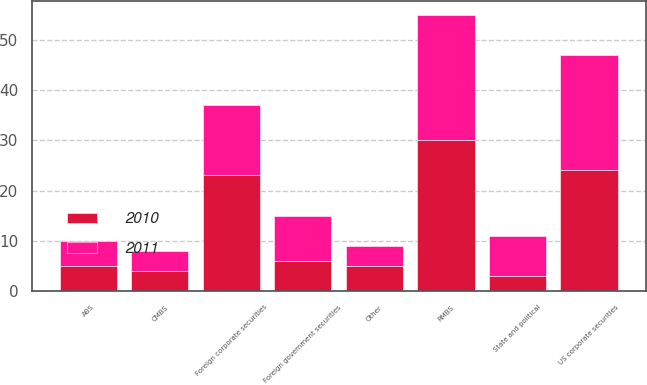Convert chart to OTSL. <chart><loc_0><loc_0><loc_500><loc_500><stacked_bar_chart><ecel><fcel>RMBS<fcel>US corporate securities<fcel>Foreign corporate securities<fcel>Foreign government securities<fcel>ABS<fcel>CMBS<fcel>State and political<fcel>Other<nl><fcel>2010<fcel>30<fcel>24<fcel>23<fcel>6<fcel>5<fcel>4<fcel>3<fcel>5<nl><fcel>2011<fcel>25<fcel>23<fcel>14<fcel>9<fcel>5<fcel>4<fcel>8<fcel>4<nl></chart> 